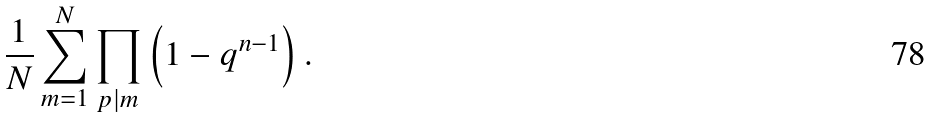<formula> <loc_0><loc_0><loc_500><loc_500>\frac { 1 } { N } \sum _ { m = 1 } ^ { N } \prod _ { p | m } \left ( 1 - q ^ { n - 1 } \right ) .</formula> 